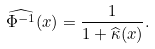<formula> <loc_0><loc_0><loc_500><loc_500>\widehat { \Phi ^ { - 1 } } ( x ) = \frac { 1 } { 1 + \widehat { \kappa } ( x ) } .</formula> 